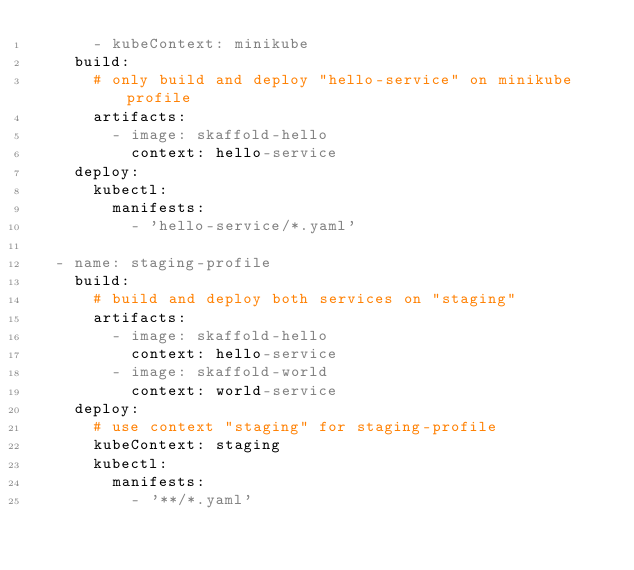Convert code to text. <code><loc_0><loc_0><loc_500><loc_500><_YAML_>      - kubeContext: minikube
    build:
      # only build and deploy "hello-service" on minikube profile
      artifacts:
        - image: skaffold-hello
          context: hello-service
    deploy:
      kubectl:
        manifests:
          - 'hello-service/*.yaml'

  - name: staging-profile
    build:
      # build and deploy both services on "staging"
      artifacts:
        - image: skaffold-hello
          context: hello-service
        - image: skaffold-world
          context: world-service
    deploy:
      # use context "staging" for staging-profile
      kubeContext: staging
      kubectl:
        manifests:
          - '**/*.yaml'
</code> 